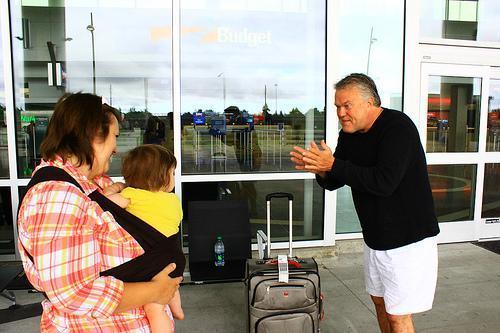How many bags are there?
Give a very brief answer. 2. 